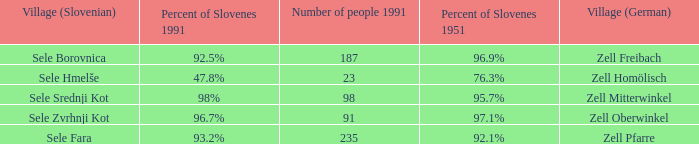Provide me with the name of the village (German) where there is 96.9% Slovenes in 1951.  Zell Freibach. 